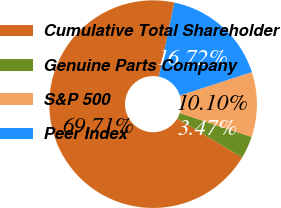Convert chart. <chart><loc_0><loc_0><loc_500><loc_500><pie_chart><fcel>Cumulative Total Shareholder<fcel>Genuine Parts Company<fcel>S&P 500<fcel>Peer Index<nl><fcel>69.71%<fcel>3.47%<fcel>10.1%<fcel>16.72%<nl></chart> 